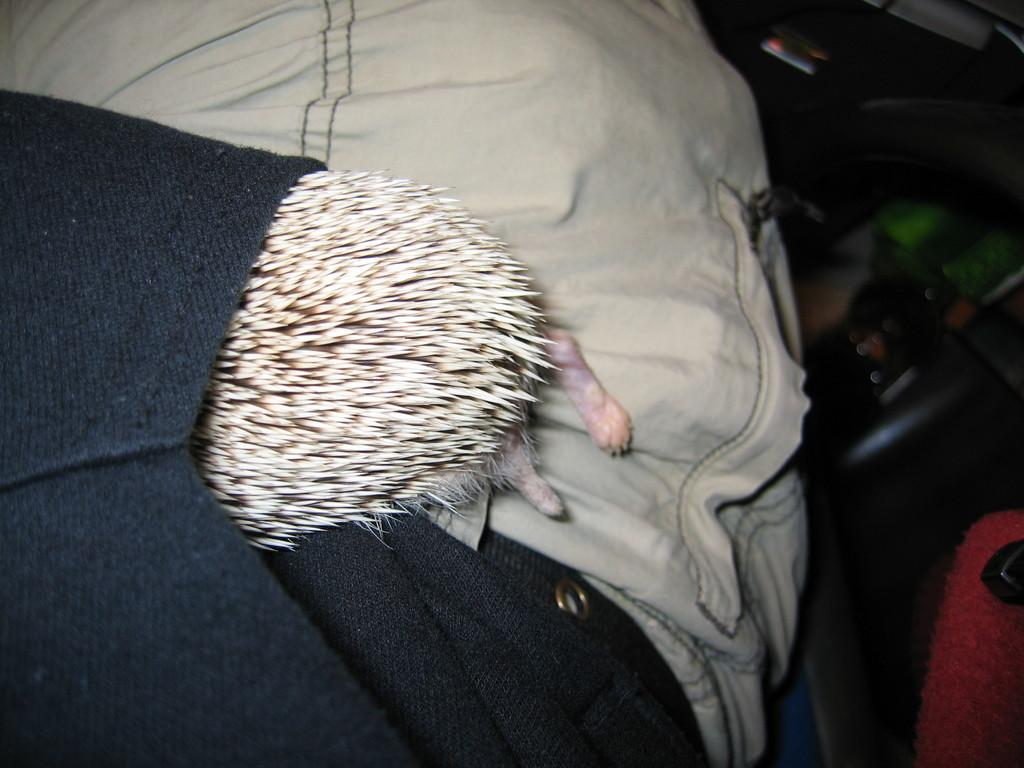What is inside the pocket of the person's hoodie in the image? There is a pet inside the pocket of the person's hoodie in the image. How many ants can be seen crawling on the watch in the image? There is no watch or ants present in the image. 